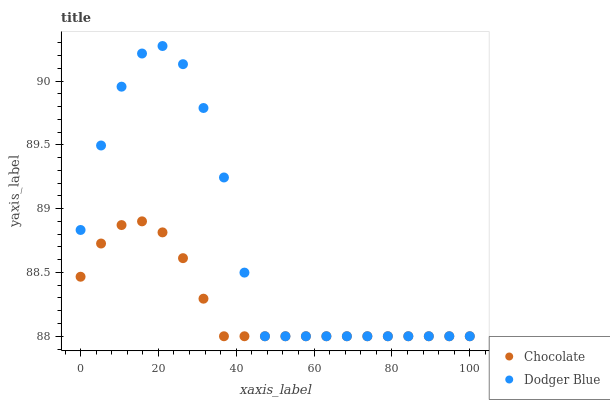Does Chocolate have the minimum area under the curve?
Answer yes or no. Yes. Does Dodger Blue have the maximum area under the curve?
Answer yes or no. Yes. Does Chocolate have the maximum area under the curve?
Answer yes or no. No. Is Chocolate the smoothest?
Answer yes or no. Yes. Is Dodger Blue the roughest?
Answer yes or no. Yes. Is Chocolate the roughest?
Answer yes or no. No. Does Dodger Blue have the lowest value?
Answer yes or no. Yes. Does Dodger Blue have the highest value?
Answer yes or no. Yes. Does Chocolate have the highest value?
Answer yes or no. No. Does Dodger Blue intersect Chocolate?
Answer yes or no. Yes. Is Dodger Blue less than Chocolate?
Answer yes or no. No. Is Dodger Blue greater than Chocolate?
Answer yes or no. No. 